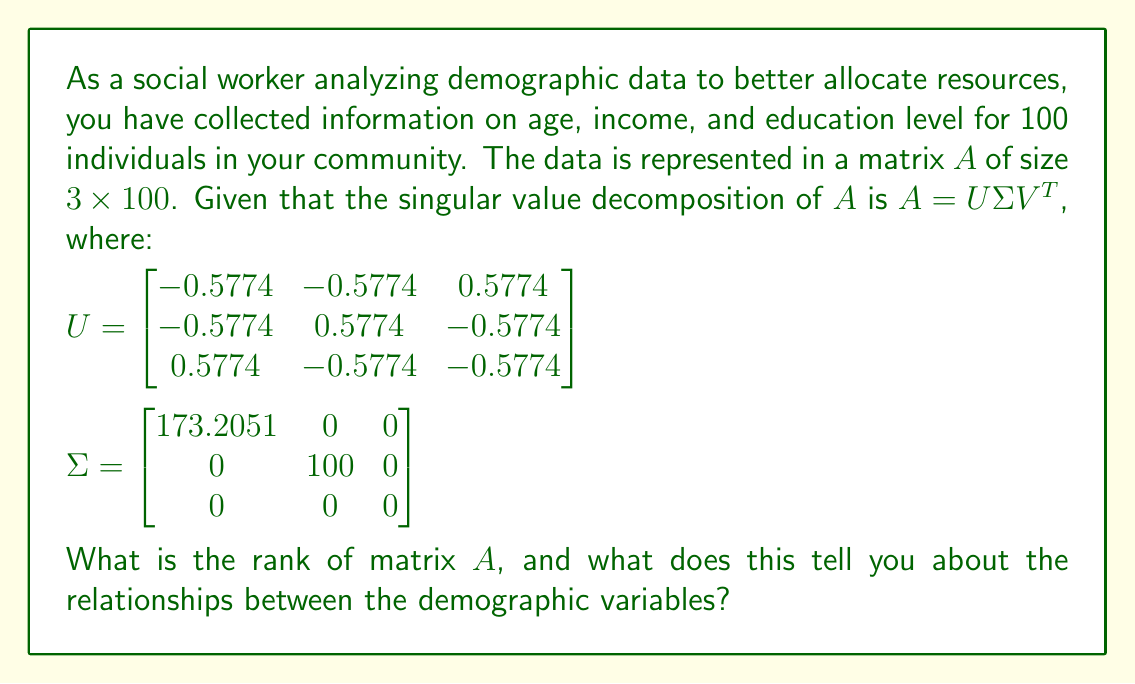Can you answer this question? To determine the rank of matrix $A$ and interpret its meaning, we'll follow these steps:

1) Recall that the rank of a matrix is equal to the number of non-zero singular values in its singular value decomposition.

2) Examine the $\Sigma$ matrix:
   $\Sigma = \begin{bmatrix}
   173.2051 & 0 & 0 \\
   0 & 100 & 0 \\
   0 & 0 & 0
   \end{bmatrix}$

3) Count the number of non-zero singular values:
   - $\sigma_1 = 173.2051$
   - $\sigma_2 = 100$
   - $\sigma_3 = 0$

4) There are two non-zero singular values, so the rank of matrix $A$ is 2.

5) Interpretation:
   - The rank being 2 (less than the number of variables, which is 3) indicates that there is a linear dependency among the demographic variables.
   - This means that one of the variables (age, income, or education level) can be expressed as a linear combination of the other two.
   - In the context of social work, this suggests that these demographic factors are closely related and not entirely independent.
   - For resource allocation, this implies that targeting interventions based on two of these factors might effectively address all three, as they are not providing completely distinct information.

6) The magnitude of the singular values also provides information:
   - The larger first singular value ($173.2051$) indicates a strong primary pattern in the data.
   - The second singular value ($100$) suggests a significant secondary pattern.
   - These patterns represent the most important relationships in the demographic data, which could be useful for identifying key areas for resource allocation.
Answer: Rank: 2. Indicates linear dependency among demographic variables, suggesting interrelated factors for resource allocation. 